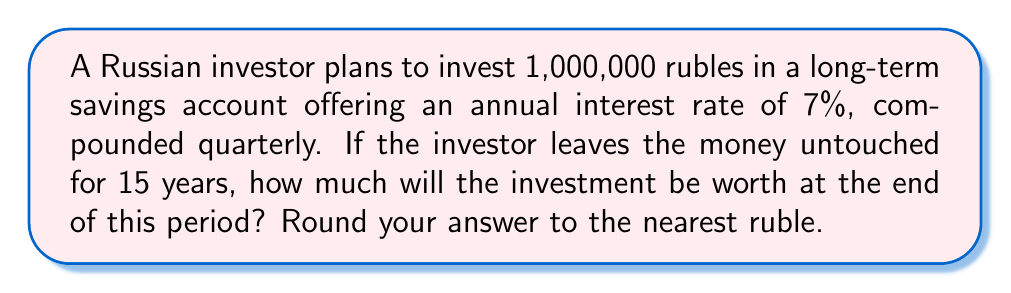Solve this math problem. To solve this problem, we'll use the compound interest formula:

$$A = P(1 + \frac{r}{n})^{nt}$$

Where:
$A$ = final amount
$P$ = principal (initial investment)
$r$ = annual interest rate (as a decimal)
$n$ = number of times interest is compounded per year
$t$ = number of years

Given:
$P = 1,000,000$ rubles
$r = 0.07$ (7% expressed as a decimal)
$n = 4$ (compounded quarterly)
$t = 15$ years

Step 1: Substitute the values into the formula:

$$A = 1,000,000(1 + \frac{0.07}{4})^{4 \times 15}$$

Step 2: Simplify the expression inside the parentheses:

$$A = 1,000,000(1 + 0.0175)^{60}$$

Step 3: Calculate the value inside the parentheses:

$$A = 1,000,000(1.0175)^{60}$$

Step 4: Use a calculator to compute the result:

$$A = 1,000,000 \times 2.8024$$

$$A = 2,802,400.78$$

Step 5: Round to the nearest ruble:

$$A = 2,802,401 \text{ rubles}$$
Answer: 2,802,401 rubles 